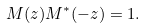Convert formula to latex. <formula><loc_0><loc_0><loc_500><loc_500>M ( z ) M ^ { * } ( - z ) & = 1 .</formula> 